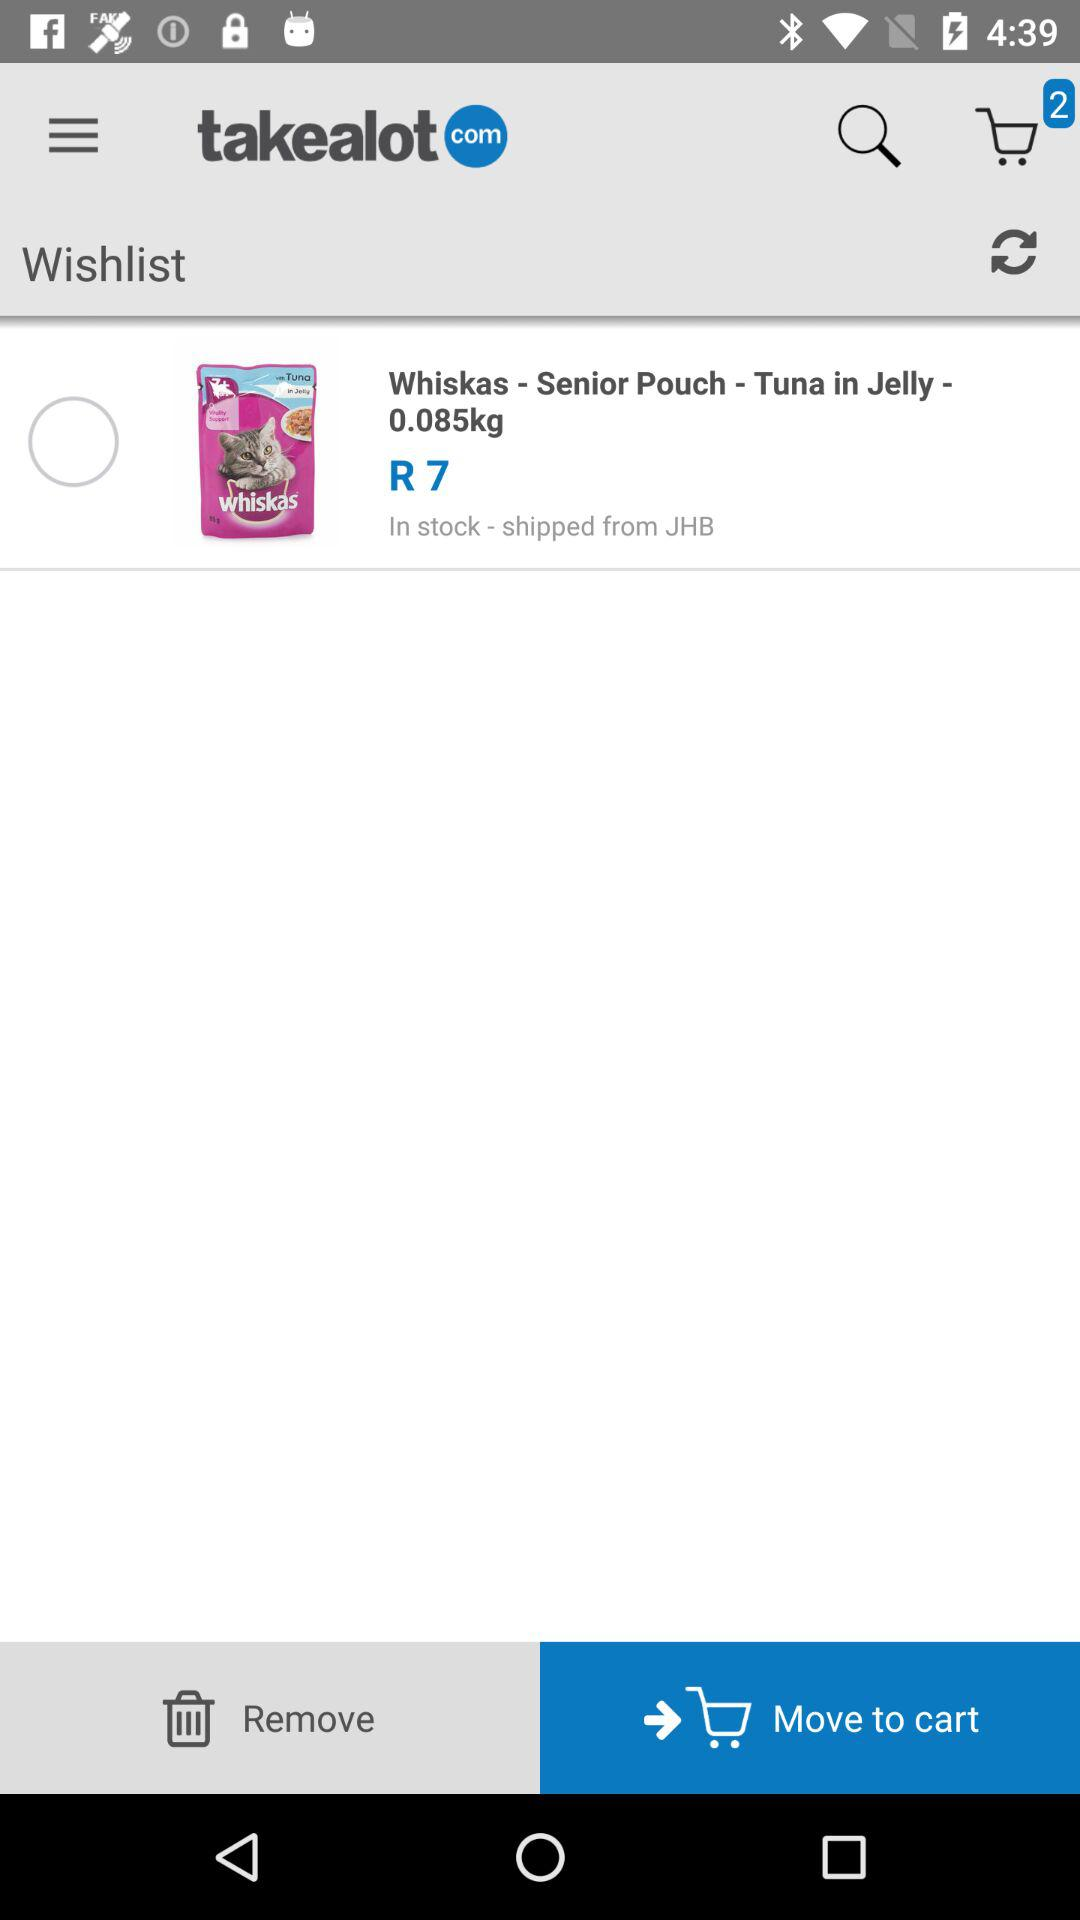What is the status of "Whiskas"? The status is "off". 